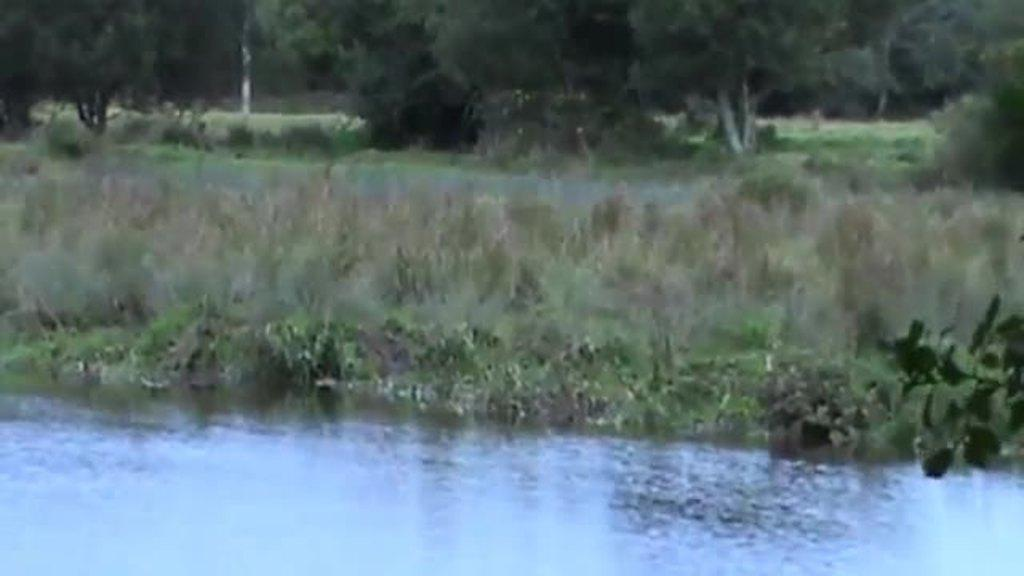What type of setting is depicted in the image? The image is an outside view. What can be seen at the bottom of the image? There is water visible at the bottom of the image. What is located in the middle of the image? There are plants in the middle of the image. What is visible in the background of the image? There are many trees in the background of the image. Can you see a baseball game happening in the image? There is no baseball game present in the image. How many geese are visible in the image? There are no geese visible in the image. 